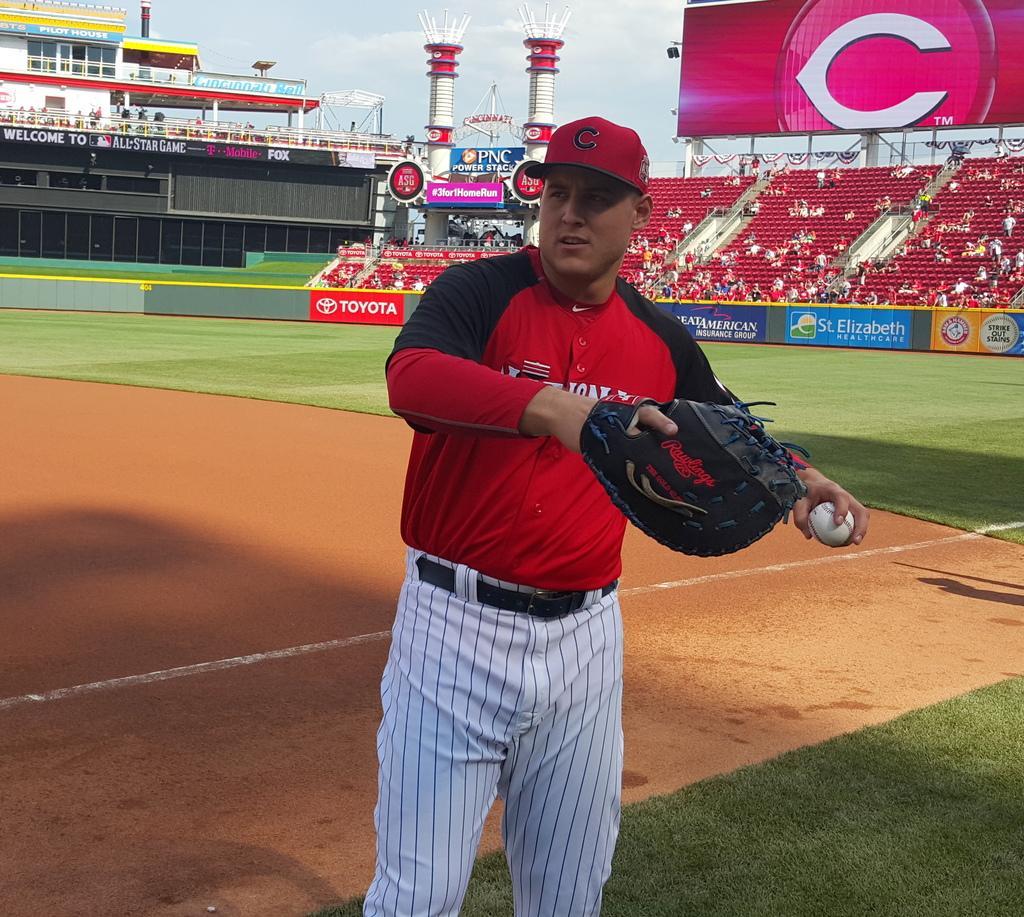Describe this image in one or two sentences. This image is taken in a playground. In the center we can see a man wearing gloves and holding a ball. In the background we can see the grass and we can also see many people sitting on the chairs. There is also hoardings and screen and also arch. Sky is also visible. 